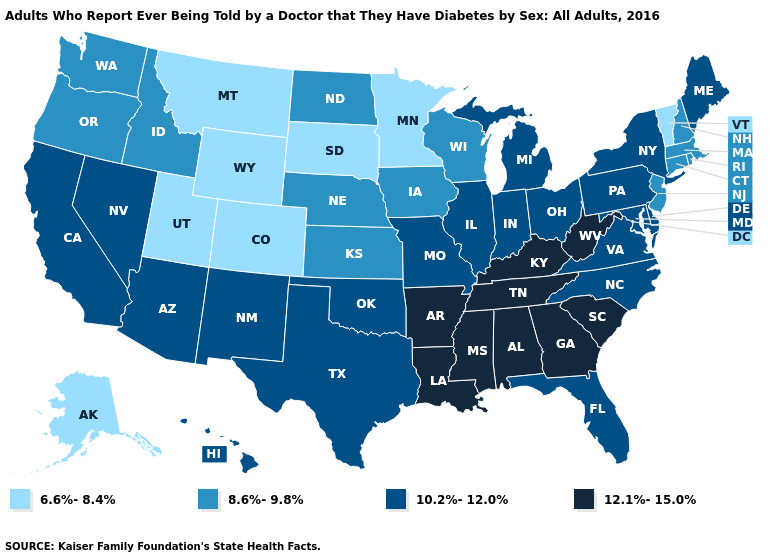Name the states that have a value in the range 8.6%-9.8%?
Give a very brief answer. Connecticut, Idaho, Iowa, Kansas, Massachusetts, Nebraska, New Hampshire, New Jersey, North Dakota, Oregon, Rhode Island, Washington, Wisconsin. What is the value of Ohio?
Be succinct. 10.2%-12.0%. Name the states that have a value in the range 6.6%-8.4%?
Quick response, please. Alaska, Colorado, Minnesota, Montana, South Dakota, Utah, Vermont, Wyoming. What is the lowest value in the USA?
Be succinct. 6.6%-8.4%. Which states have the lowest value in the West?
Keep it brief. Alaska, Colorado, Montana, Utah, Wyoming. Does Delaware have a lower value than Minnesota?
Quick response, please. No. What is the value of Oregon?
Write a very short answer. 8.6%-9.8%. What is the value of Nebraska?
Give a very brief answer. 8.6%-9.8%. What is the lowest value in states that border South Dakota?
Concise answer only. 6.6%-8.4%. What is the value of Florida?
Write a very short answer. 10.2%-12.0%. What is the value of Arizona?
Short answer required. 10.2%-12.0%. Name the states that have a value in the range 6.6%-8.4%?
Quick response, please. Alaska, Colorado, Minnesota, Montana, South Dakota, Utah, Vermont, Wyoming. What is the value of Michigan?
Keep it brief. 10.2%-12.0%. What is the highest value in the MidWest ?
Keep it brief. 10.2%-12.0%. What is the value of New Jersey?
Concise answer only. 8.6%-9.8%. 